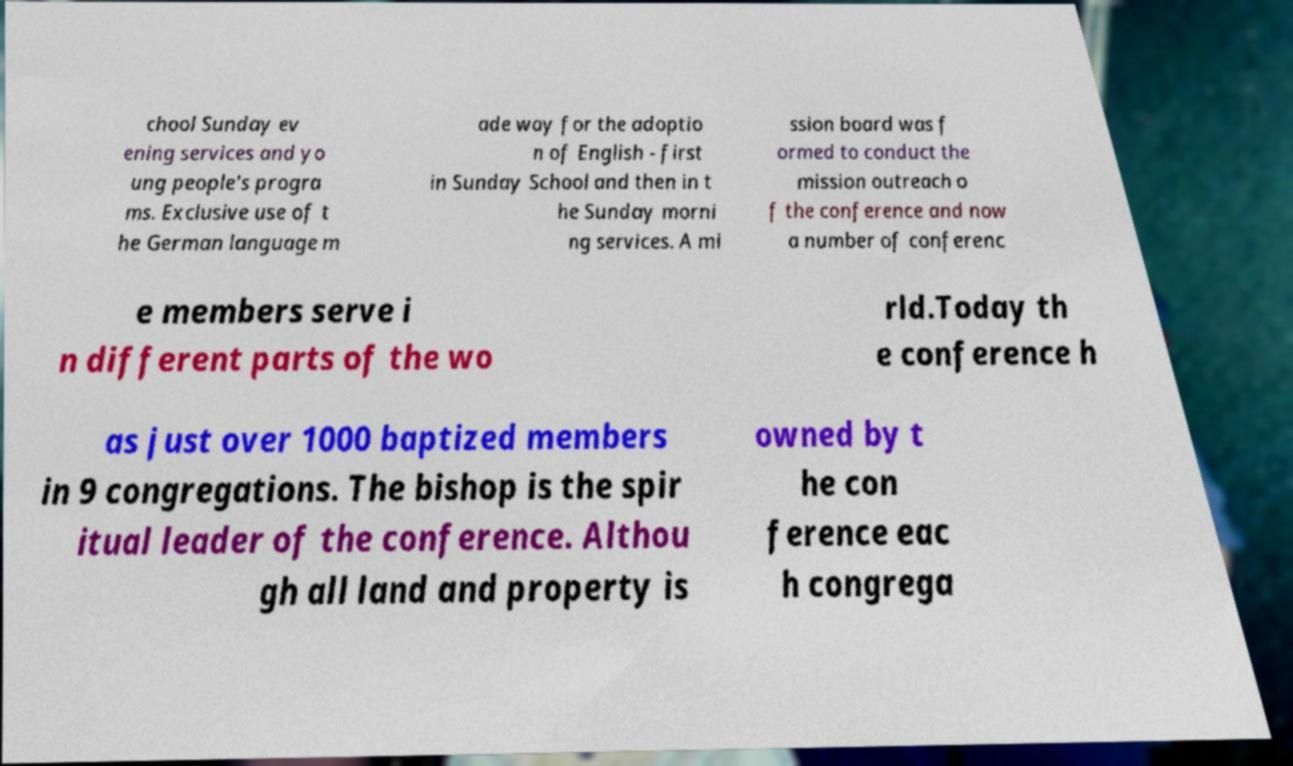Can you read and provide the text displayed in the image?This photo seems to have some interesting text. Can you extract and type it out for me? chool Sunday ev ening services and yo ung people's progra ms. Exclusive use of t he German language m ade way for the adoptio n of English - first in Sunday School and then in t he Sunday morni ng services. A mi ssion board was f ormed to conduct the mission outreach o f the conference and now a number of conferenc e members serve i n different parts of the wo rld.Today th e conference h as just over 1000 baptized members in 9 congregations. The bishop is the spir itual leader of the conference. Althou gh all land and property is owned by t he con ference eac h congrega 